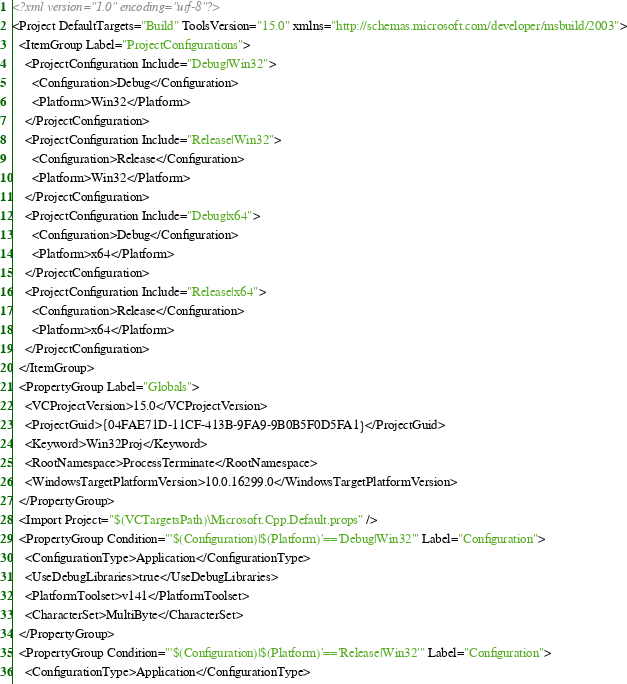Convert code to text. <code><loc_0><loc_0><loc_500><loc_500><_XML_><?xml version="1.0" encoding="utf-8"?>
<Project DefaultTargets="Build" ToolsVersion="15.0" xmlns="http://schemas.microsoft.com/developer/msbuild/2003">
  <ItemGroup Label="ProjectConfigurations">
    <ProjectConfiguration Include="Debug|Win32">
      <Configuration>Debug</Configuration>
      <Platform>Win32</Platform>
    </ProjectConfiguration>
    <ProjectConfiguration Include="Release|Win32">
      <Configuration>Release</Configuration>
      <Platform>Win32</Platform>
    </ProjectConfiguration>
    <ProjectConfiguration Include="Debug|x64">
      <Configuration>Debug</Configuration>
      <Platform>x64</Platform>
    </ProjectConfiguration>
    <ProjectConfiguration Include="Release|x64">
      <Configuration>Release</Configuration>
      <Platform>x64</Platform>
    </ProjectConfiguration>
  </ItemGroup>
  <PropertyGroup Label="Globals">
    <VCProjectVersion>15.0</VCProjectVersion>
    <ProjectGuid>{04FAE71D-11CF-413B-9FA9-9B0B5F0D5FA1}</ProjectGuid>
    <Keyword>Win32Proj</Keyword>
    <RootNamespace>ProcessTerminate</RootNamespace>
    <WindowsTargetPlatformVersion>10.0.16299.0</WindowsTargetPlatformVersion>
  </PropertyGroup>
  <Import Project="$(VCTargetsPath)\Microsoft.Cpp.Default.props" />
  <PropertyGroup Condition="'$(Configuration)|$(Platform)'=='Debug|Win32'" Label="Configuration">
    <ConfigurationType>Application</ConfigurationType>
    <UseDebugLibraries>true</UseDebugLibraries>
    <PlatformToolset>v141</PlatformToolset>
    <CharacterSet>MultiByte</CharacterSet>
  </PropertyGroup>
  <PropertyGroup Condition="'$(Configuration)|$(Platform)'=='Release|Win32'" Label="Configuration">
    <ConfigurationType>Application</ConfigurationType></code> 